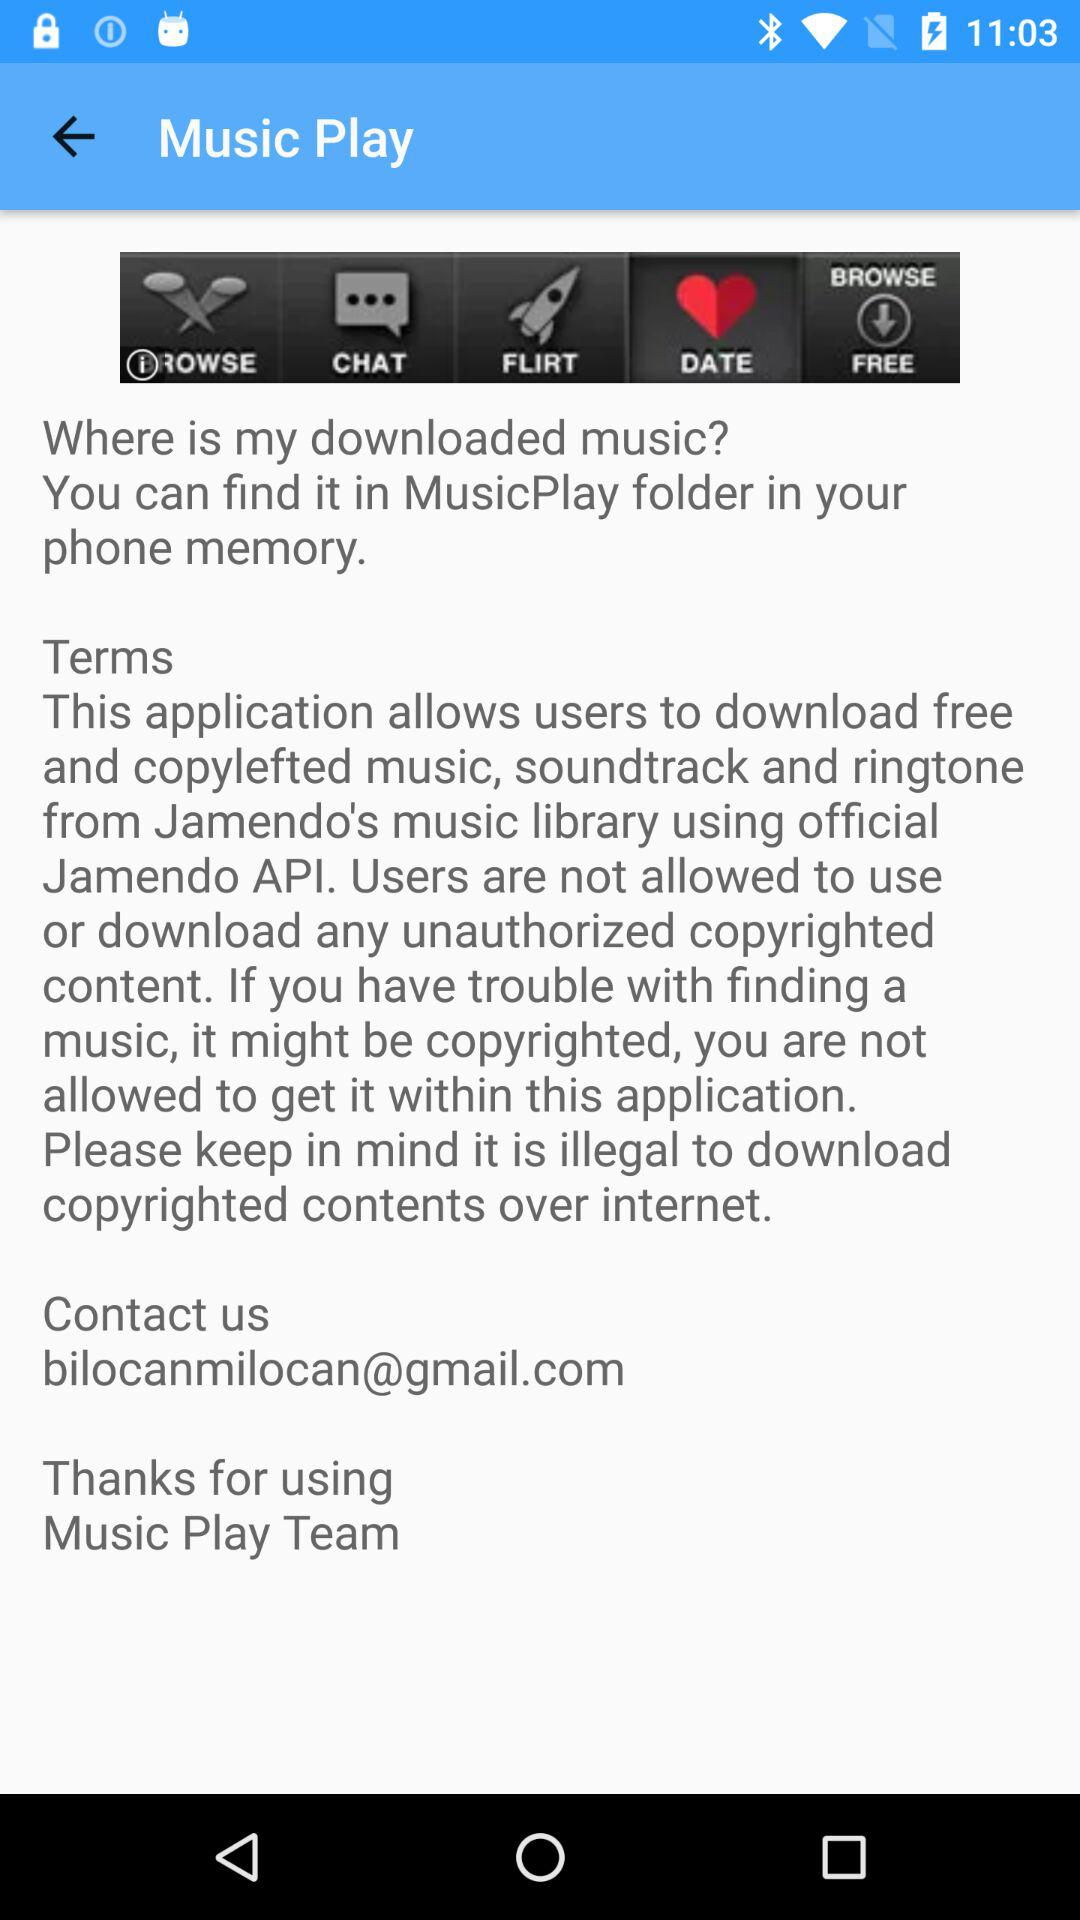Where can we contact for any query related to music download? You can contact bilocanmilocan@gmail.com for any query related to music download. 